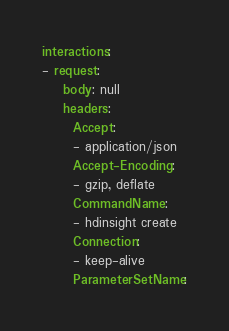<code> <loc_0><loc_0><loc_500><loc_500><_YAML_>interactions:
- request:
    body: null
    headers:
      Accept:
      - application/json
      Accept-Encoding:
      - gzip, deflate
      CommandName:
      - hdinsight create
      Connection:
      - keep-alive
      ParameterSetName:</code> 